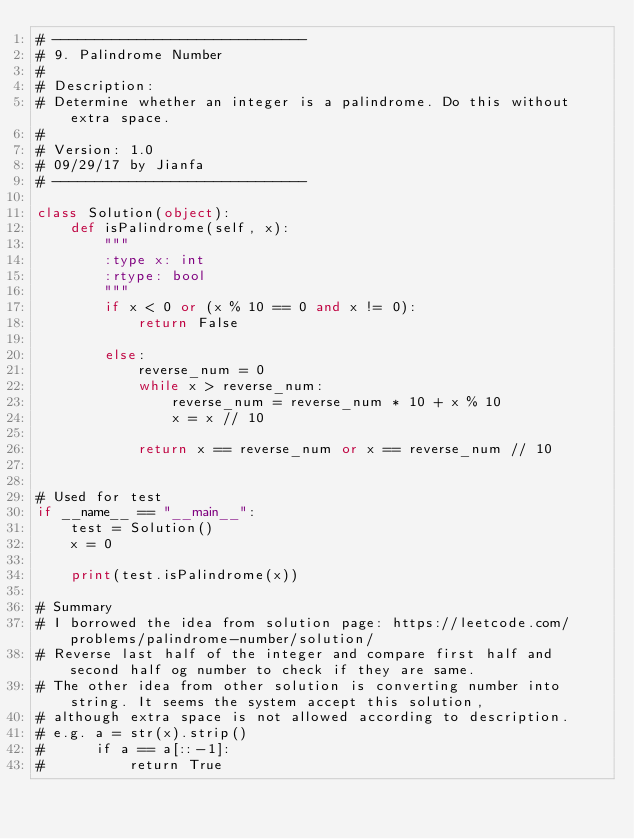Convert code to text. <code><loc_0><loc_0><loc_500><loc_500><_Python_># ------------------------------
# 9. Palindrome Number
# 
# Description:
# Determine whether an integer is a palindrome. Do this without extra space.
# 
# Version: 1.0
# 09/29/17 by Jianfa
# ------------------------------

class Solution(object):
    def isPalindrome(self, x):
        """
        :type x: int
        :rtype: bool
        """
        if x < 0 or (x % 10 == 0 and x != 0):
            return False

        else:
            reverse_num = 0
            while x > reverse_num:
                reverse_num = reverse_num * 10 + x % 10
                x = x // 10
            
            return x == reverse_num or x == reverse_num // 10
    

# Used for test
if __name__ == "__main__":
    test = Solution()
    x = 0
    
    print(test.isPalindrome(x)) 

# Summary
# I borrowed the idea from solution page: https://leetcode.com/problems/palindrome-number/solution/
# Reverse last half of the integer and compare first half and second half og number to check if they are same.
# The other idea from other solution is converting number into string. It seems the system accept this solution,
# although extra space is not allowed according to description.
# e.g. a = str(x).strip()
#      if a == a[::-1]:
#          return True</code> 